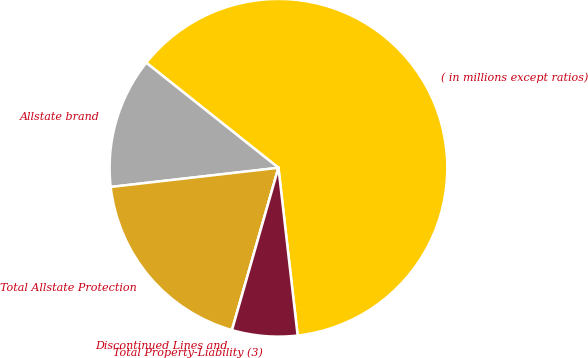Convert chart to OTSL. <chart><loc_0><loc_0><loc_500><loc_500><pie_chart><fcel>( in millions except ratios)<fcel>Allstate brand<fcel>Total Allstate Protection<fcel>Discontinued Lines and<fcel>Total Property-Liability (3)<nl><fcel>62.49%<fcel>12.5%<fcel>18.75%<fcel>0.0%<fcel>6.25%<nl></chart> 